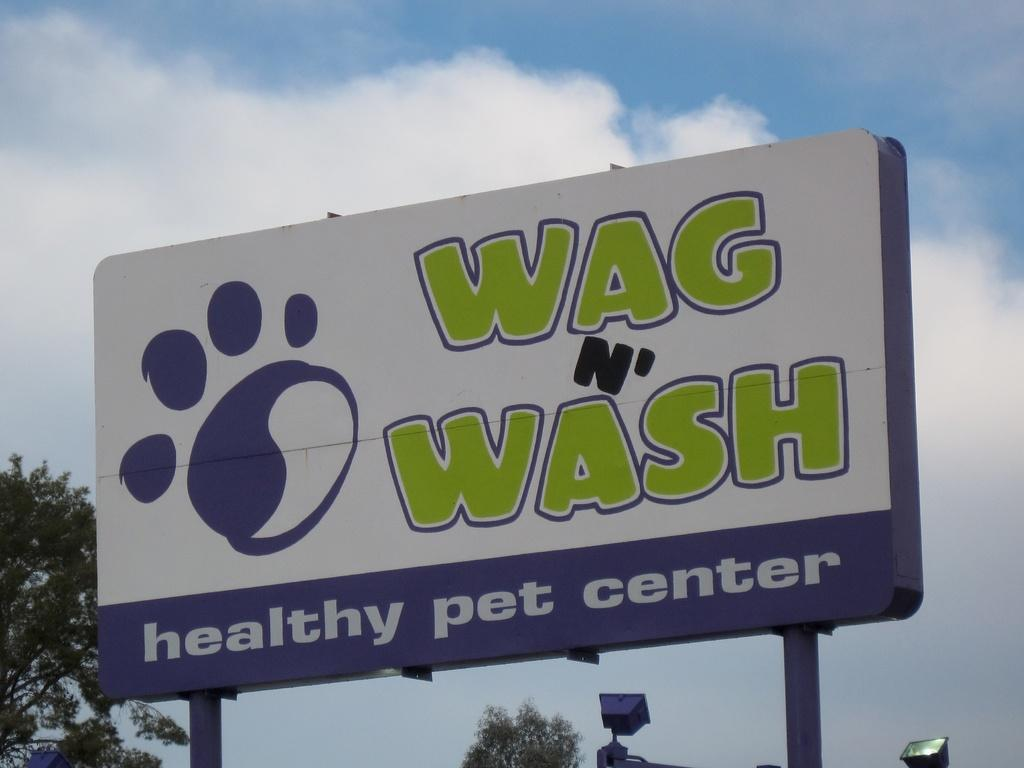<image>
Present a compact description of the photo's key features. A sign for a healthy pet center called Wag N' Wash 